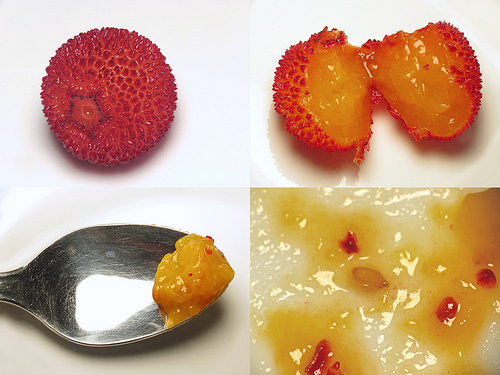<image>
Is there a spoon under the fruit? Yes. The spoon is positioned underneath the fruit, with the fruit above it in the vertical space. Is there a food on the spoon? Yes. Looking at the image, I can see the food is positioned on top of the spoon, with the spoon providing support. 